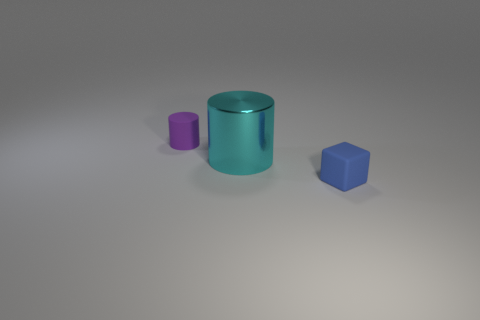Subtract 0 green cylinders. How many objects are left? 3 Subtract all blocks. How many objects are left? 2 Subtract 1 cubes. How many cubes are left? 0 Subtract all green cubes. Subtract all red spheres. How many cubes are left? 1 Subtract all yellow cubes. How many purple cylinders are left? 1 Subtract all tiny blue cylinders. Subtract all large metallic things. How many objects are left? 2 Add 2 cyan cylinders. How many cyan cylinders are left? 3 Add 1 red metallic cubes. How many red metallic cubes exist? 1 Add 1 cyan cylinders. How many objects exist? 4 Subtract all purple cylinders. How many cylinders are left? 1 